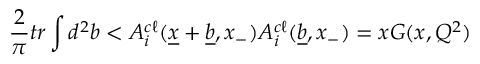Convert formula to latex. <formula><loc_0><loc_0><loc_500><loc_500>{ \frac { 2 } { \pi } } t r \int d ^ { 2 } b < A _ { i } ^ { c \ell } ( \underline { x } + \underline { b } , x _ { - } ) A _ { i } ^ { c \ell } ( \underline { b } , x _ { - } ) = x G ( x , Q ^ { 2 } )</formula> 